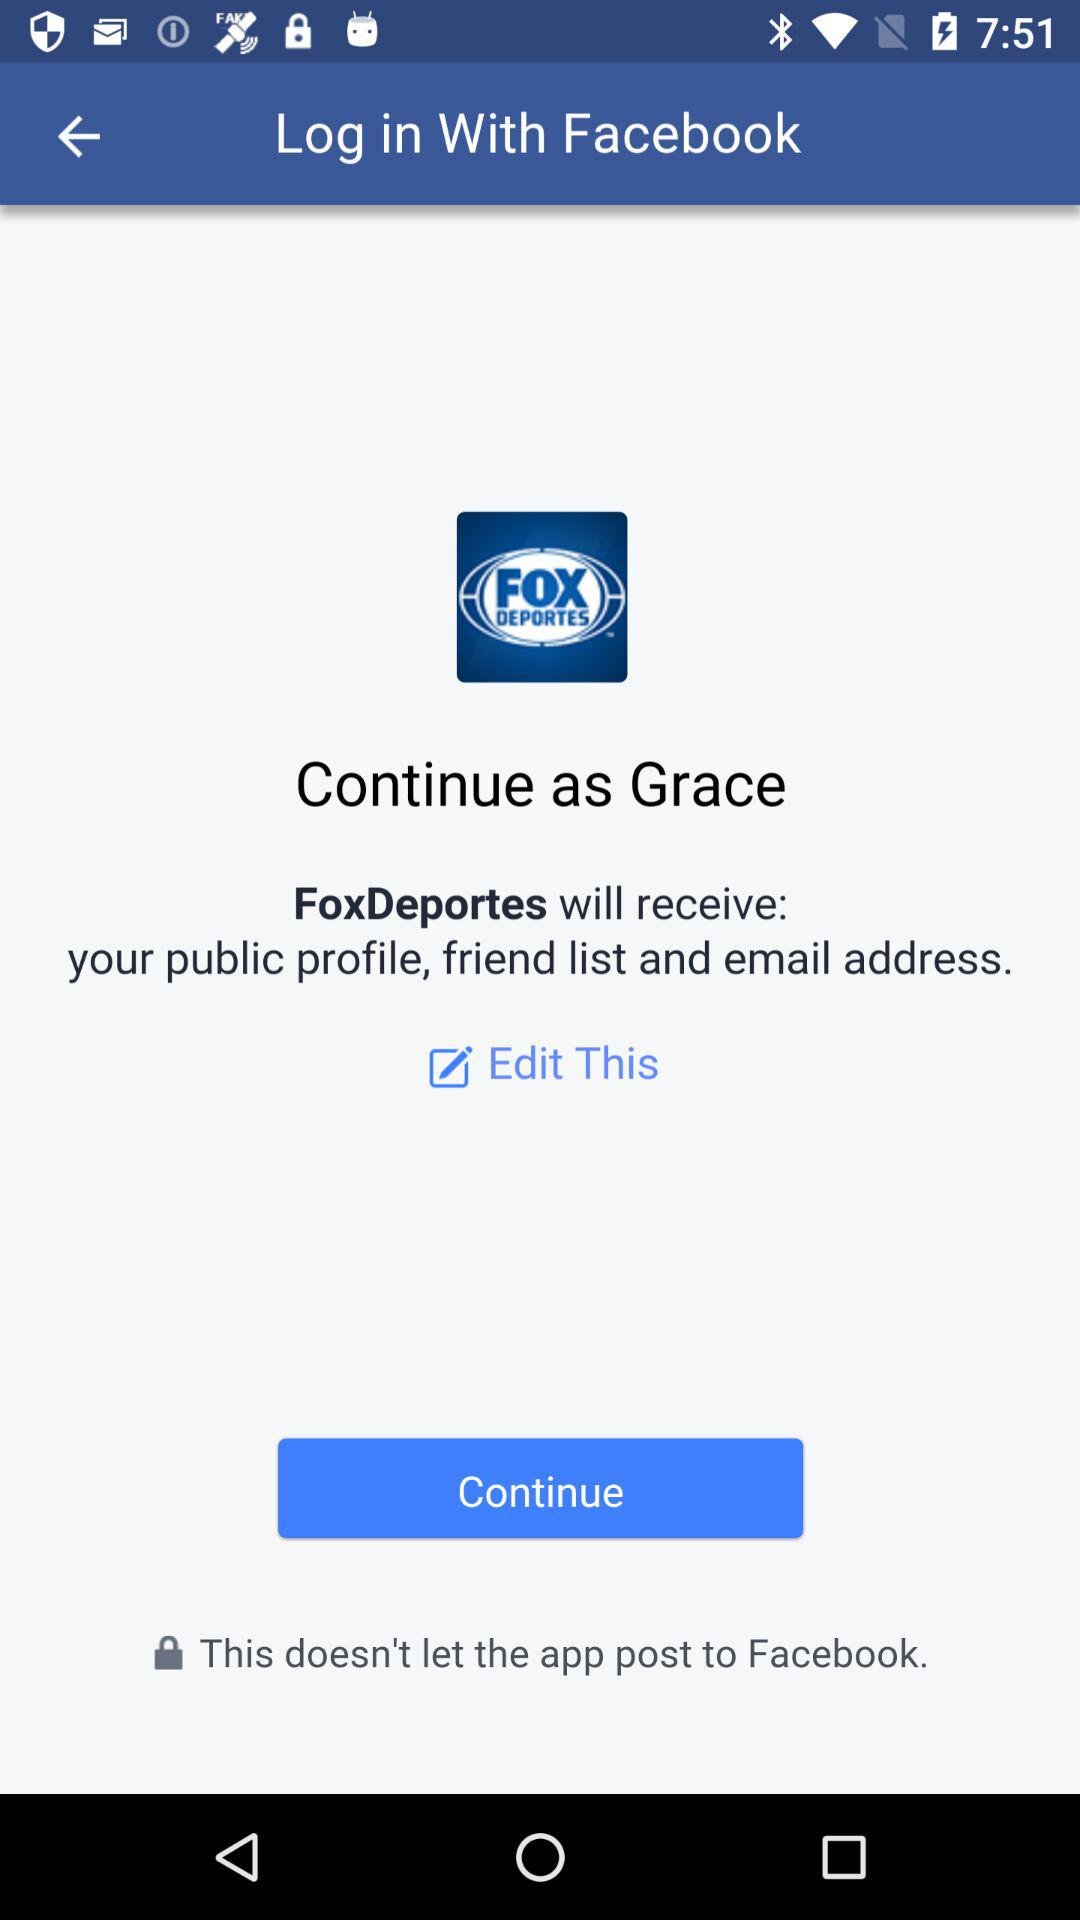How many items will FoxDeportes receive?
Answer the question using a single word or phrase. 3 